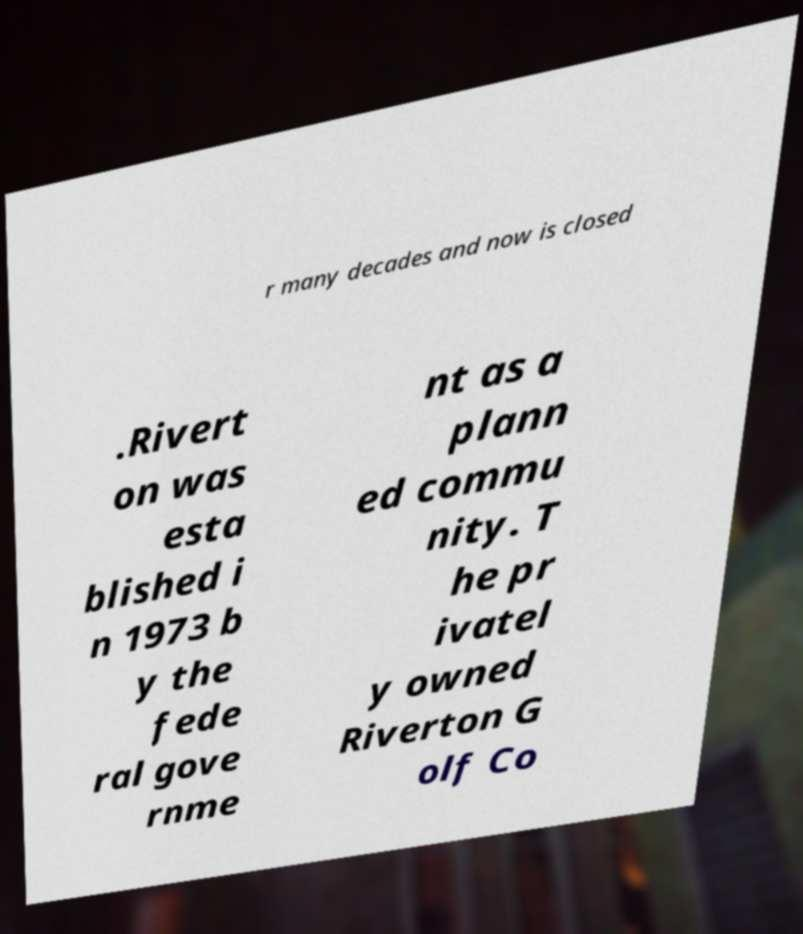Could you extract and type out the text from this image? r many decades and now is closed .Rivert on was esta blished i n 1973 b y the fede ral gove rnme nt as a plann ed commu nity. T he pr ivatel y owned Riverton G olf Co 